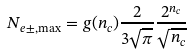Convert formula to latex. <formula><loc_0><loc_0><loc_500><loc_500>N _ { e \pm , \max } = g ( n _ { c } ) \frac { 2 } { 3 \sqrt { \pi } } \frac { 2 ^ { n _ { c } } } { \sqrt { n _ { c } } }</formula> 